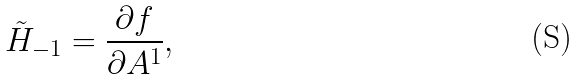Convert formula to latex. <formula><loc_0><loc_0><loc_500><loc_500>\tilde { H } _ { - 1 } = \frac { \partial f } { \partial A ^ { 1 } } ,</formula> 